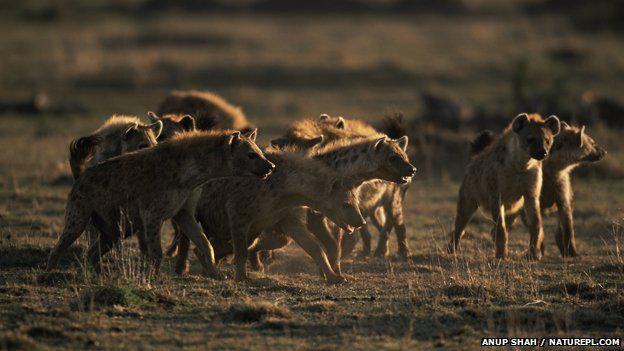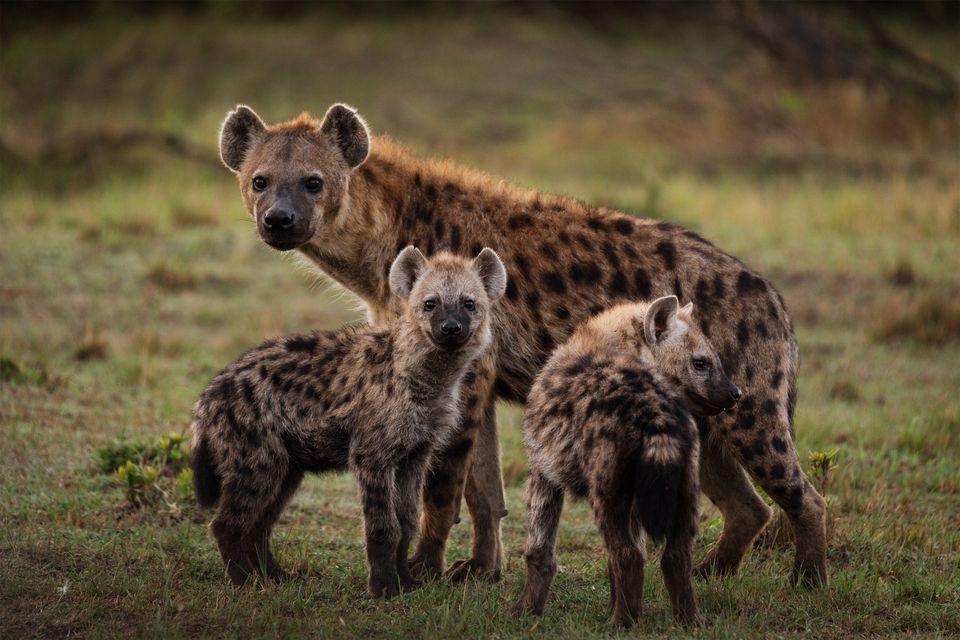The first image is the image on the left, the second image is the image on the right. For the images displayed, is the sentence "Right image shows a close grouping of no more than five hyenas." factually correct? Answer yes or no. Yes. The first image is the image on the left, the second image is the image on the right. Evaluate the accuracy of this statement regarding the images: "There are no more than 4 hyenas in one of the images". Is it true? Answer yes or no. Yes. 